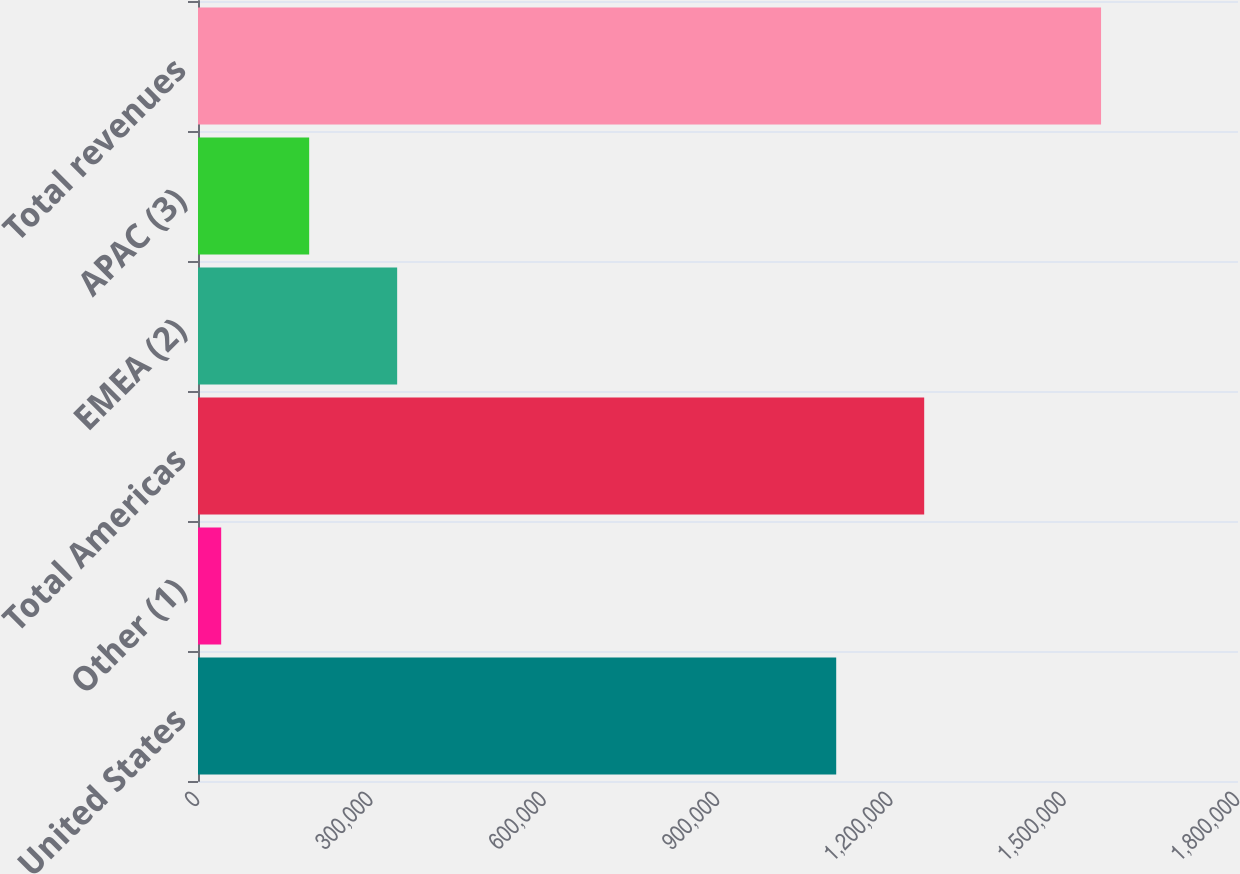Convert chart to OTSL. <chart><loc_0><loc_0><loc_500><loc_500><bar_chart><fcel>United States<fcel>Other (1)<fcel>Total Americas<fcel>EMEA (2)<fcel>APAC (3)<fcel>Total revenues<nl><fcel>1.10459e+06<fcel>40119<fcel>1.25688e+06<fcel>344695<fcel>192407<fcel>1.563e+06<nl></chart> 